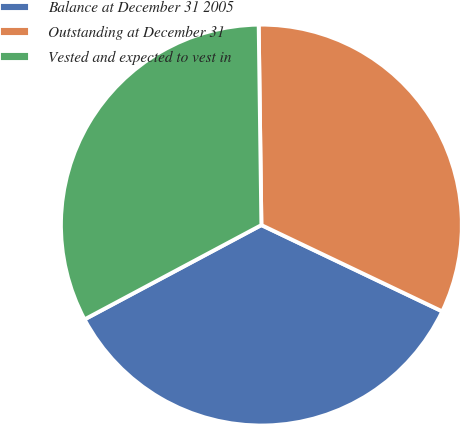<chart> <loc_0><loc_0><loc_500><loc_500><pie_chart><fcel>Balance at December 31 2005<fcel>Outstanding at December 31<fcel>Vested and expected to vest in<nl><fcel>35.11%<fcel>32.3%<fcel>32.58%<nl></chart> 